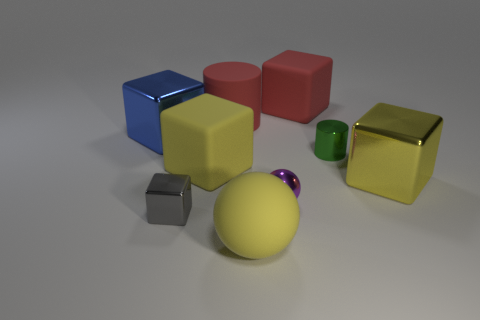Subtract all red spheres. How many yellow cubes are left? 2 Subtract 3 cubes. How many cubes are left? 2 Subtract all small gray blocks. How many blocks are left? 4 Add 1 large gray blocks. How many objects exist? 10 Subtract all blue cubes. How many cubes are left? 4 Subtract all cyan cubes. Subtract all blue balls. How many cubes are left? 5 Subtract 0 blue spheres. How many objects are left? 9 Subtract all cylinders. How many objects are left? 7 Subtract all green cylinders. Subtract all green metal objects. How many objects are left? 7 Add 5 gray blocks. How many gray blocks are left? 6 